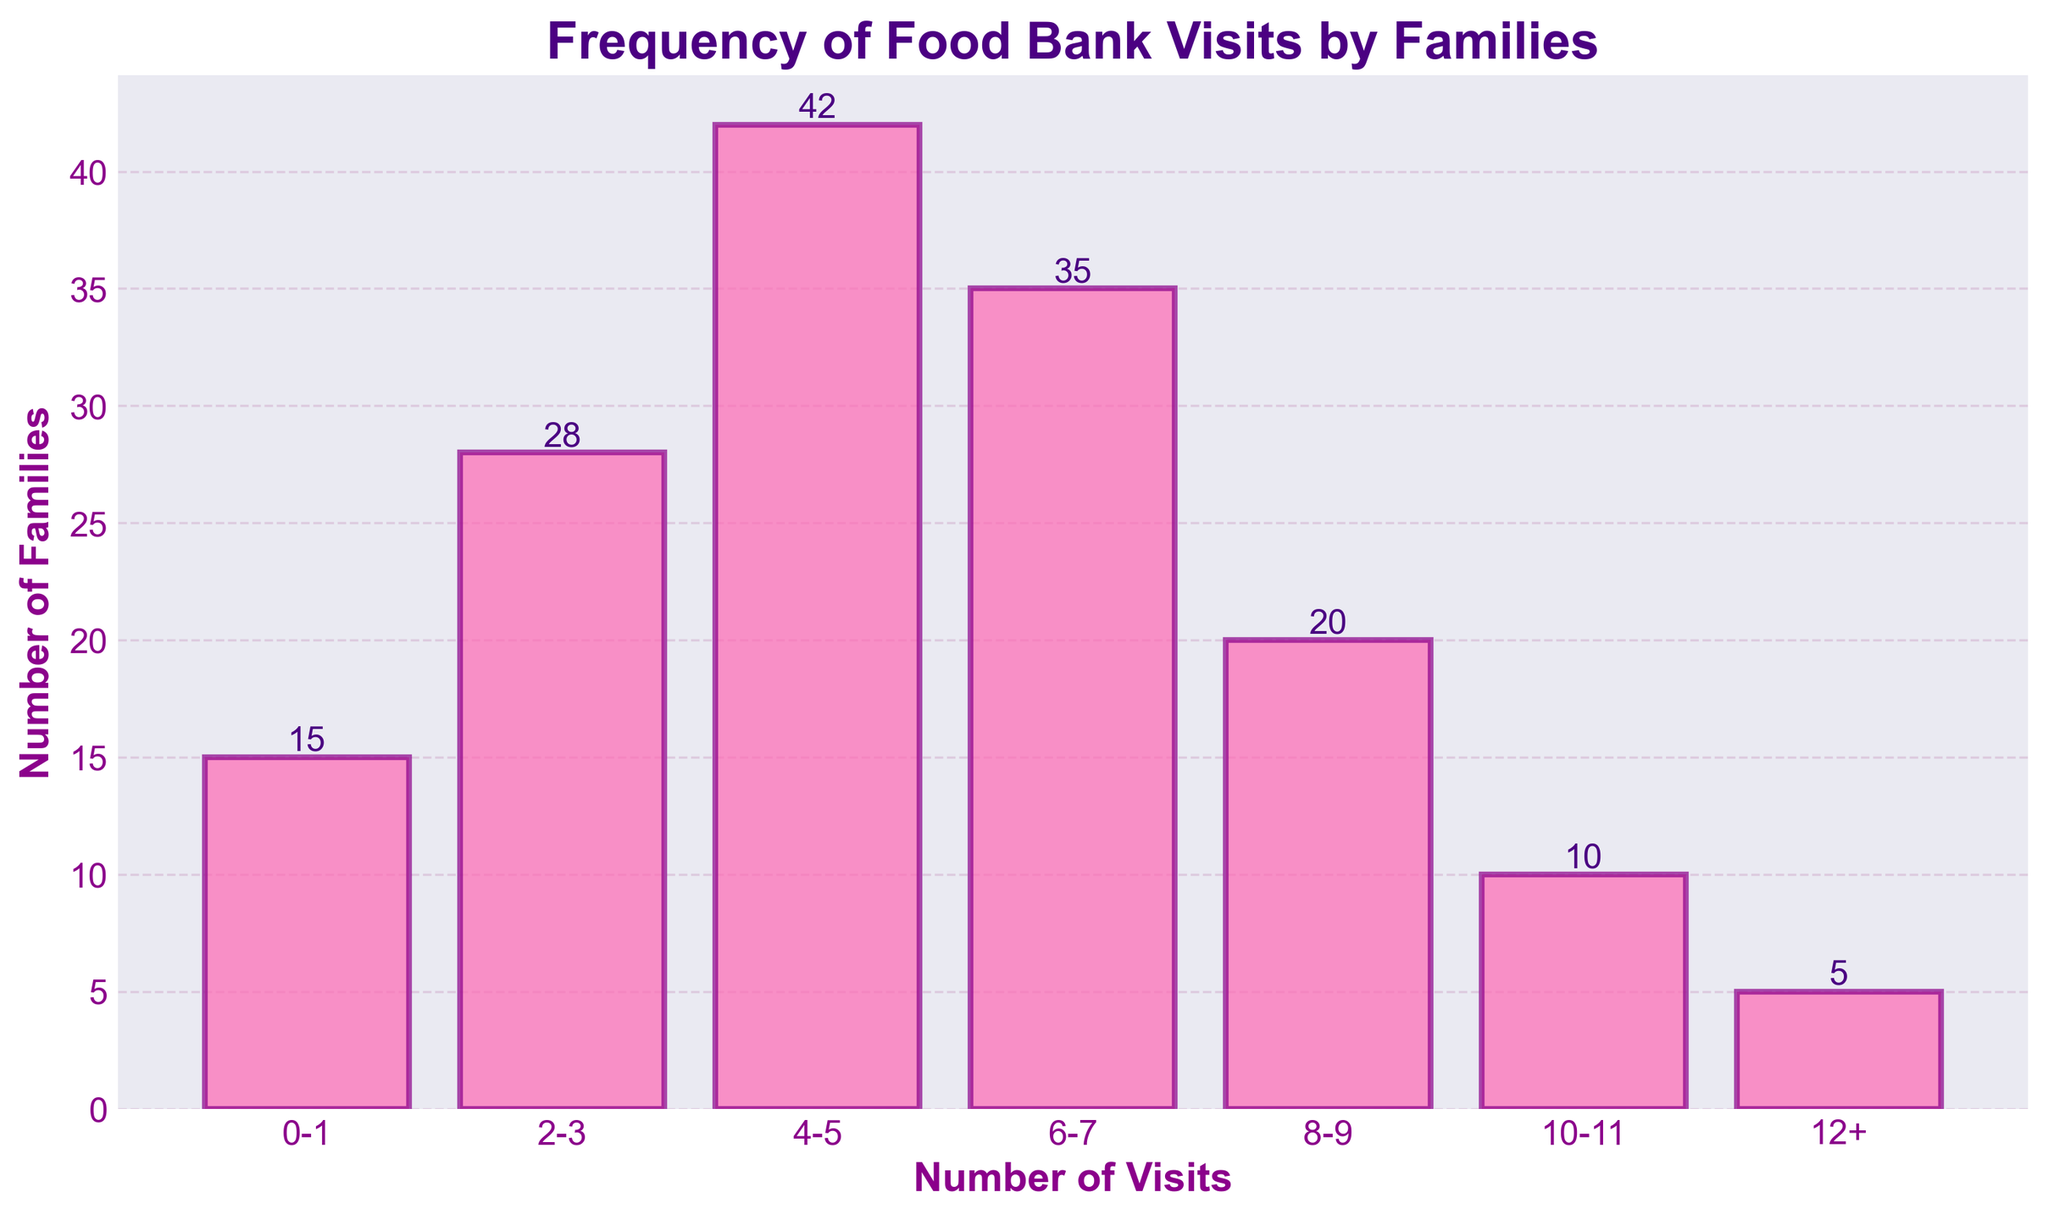What is the title of the figure? The title is written at the top of the figure and gives an overview of what the graph is about. The title is "Frequency of Food Bank Visits by Families."
Answer: Frequency of Food Bank Visits by Families How many families visited the food bank 4-5 times? Look at the bar corresponding to the 4-5 visits category on the x-axis and read its height, which indicates the number of families.
Answer: 42 Which visit range has the highest number of families? Compare the height of all the bars and find the one that is tallest. The tallest bar is for the 4-5 visits range.
Answer: 4-5 What is the total number of families that visited the food bank? Sum the heights of all the bars to get the total number of families. 15 (0-1) + 28 (2-3) + 42 (4-5) + 35 (6-7) + 20 (8-9) + 10 (10-11) + 5 (12+). Total is 155.
Answer: 155 How many fewer families visited the food bank 6-7 times compared to 4-5 times? Compute the difference between the number of families who visited 4-5 times and those who visited 6-7 times. 42 (4-5) - 35 (6-7) = 7.
Answer: 7 What percentage of the total families visited the food bank 8-9 times? Divide the number of families that visited 8-9 times by the total number of families and multiply by 100. (20 / 155) * 100 ≈ 12.9%.
Answer: 12.9% Which categories have fewer than 20 families? Identify all bars where the height (number of families) is less than 20. These are the 0-1 and 12+ visit ranges.
Answer: 0-1, 12+ Is the number of families visiting the food bank 2-3 times more or less than those visiting 6-7 times? Compare the height of the bars for the 2-3 and 6-7 visit ranges. The bar for 6-7 times is taller than the 2-3 times bar.
Answer: More 